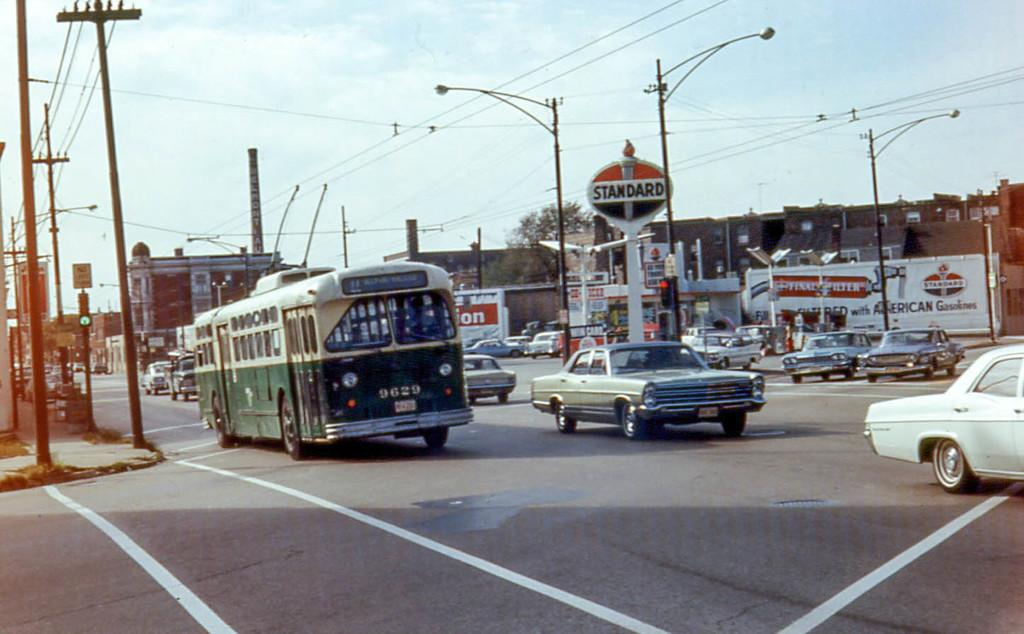<image>
Render a clear and concise summary of the photo. A signboard for Standard is over a busy street. 